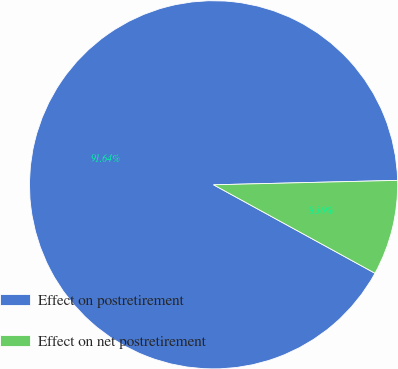Convert chart. <chart><loc_0><loc_0><loc_500><loc_500><pie_chart><fcel>Effect on postretirement<fcel>Effect on net postretirement<nl><fcel>91.64%<fcel>8.36%<nl></chart> 